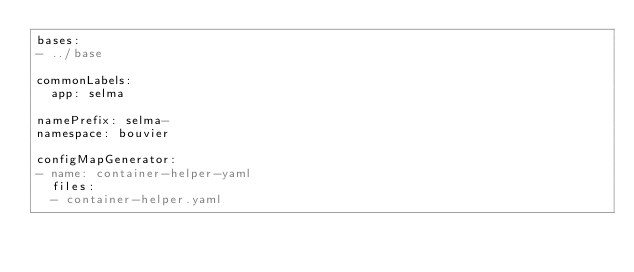<code> <loc_0><loc_0><loc_500><loc_500><_YAML_>bases:
- ../base

commonLabels:
  app: selma

namePrefix: selma-
namespace: bouvier

configMapGenerator:
- name: container-helper-yaml
  files:
  - container-helper.yaml
</code> 